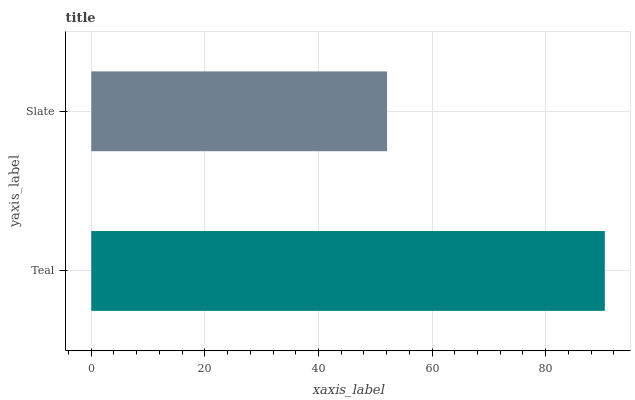Is Slate the minimum?
Answer yes or no. Yes. Is Teal the maximum?
Answer yes or no. Yes. Is Slate the maximum?
Answer yes or no. No. Is Teal greater than Slate?
Answer yes or no. Yes. Is Slate less than Teal?
Answer yes or no. Yes. Is Slate greater than Teal?
Answer yes or no. No. Is Teal less than Slate?
Answer yes or no. No. Is Teal the high median?
Answer yes or no. Yes. Is Slate the low median?
Answer yes or no. Yes. Is Slate the high median?
Answer yes or no. No. Is Teal the low median?
Answer yes or no. No. 